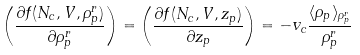Convert formula to latex. <formula><loc_0><loc_0><loc_500><loc_500>\left ( \frac { \partial f ( N _ { c } , V , \rho _ { p } ^ { r } ) } { \partial \rho _ { p } ^ { r } } \right ) = \left ( \frac { \partial f ( N _ { c } , V , z _ { p } ) } { \partial z _ { p } } \right ) = - v _ { c } \frac { \langle \rho _ { p } \rangle _ { \rho _ { p } ^ { r } } } { \rho _ { p } ^ { r } }</formula> 